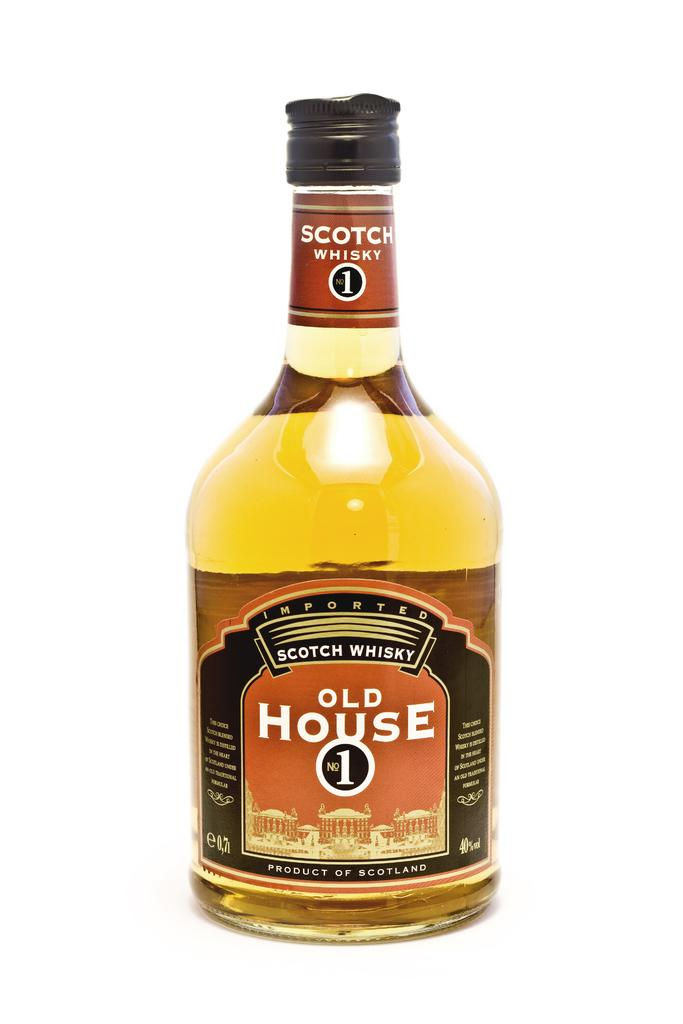<image>
Present a compact description of the photo's key features. A bottle of Old House Scotch Whiskey stands alone. 